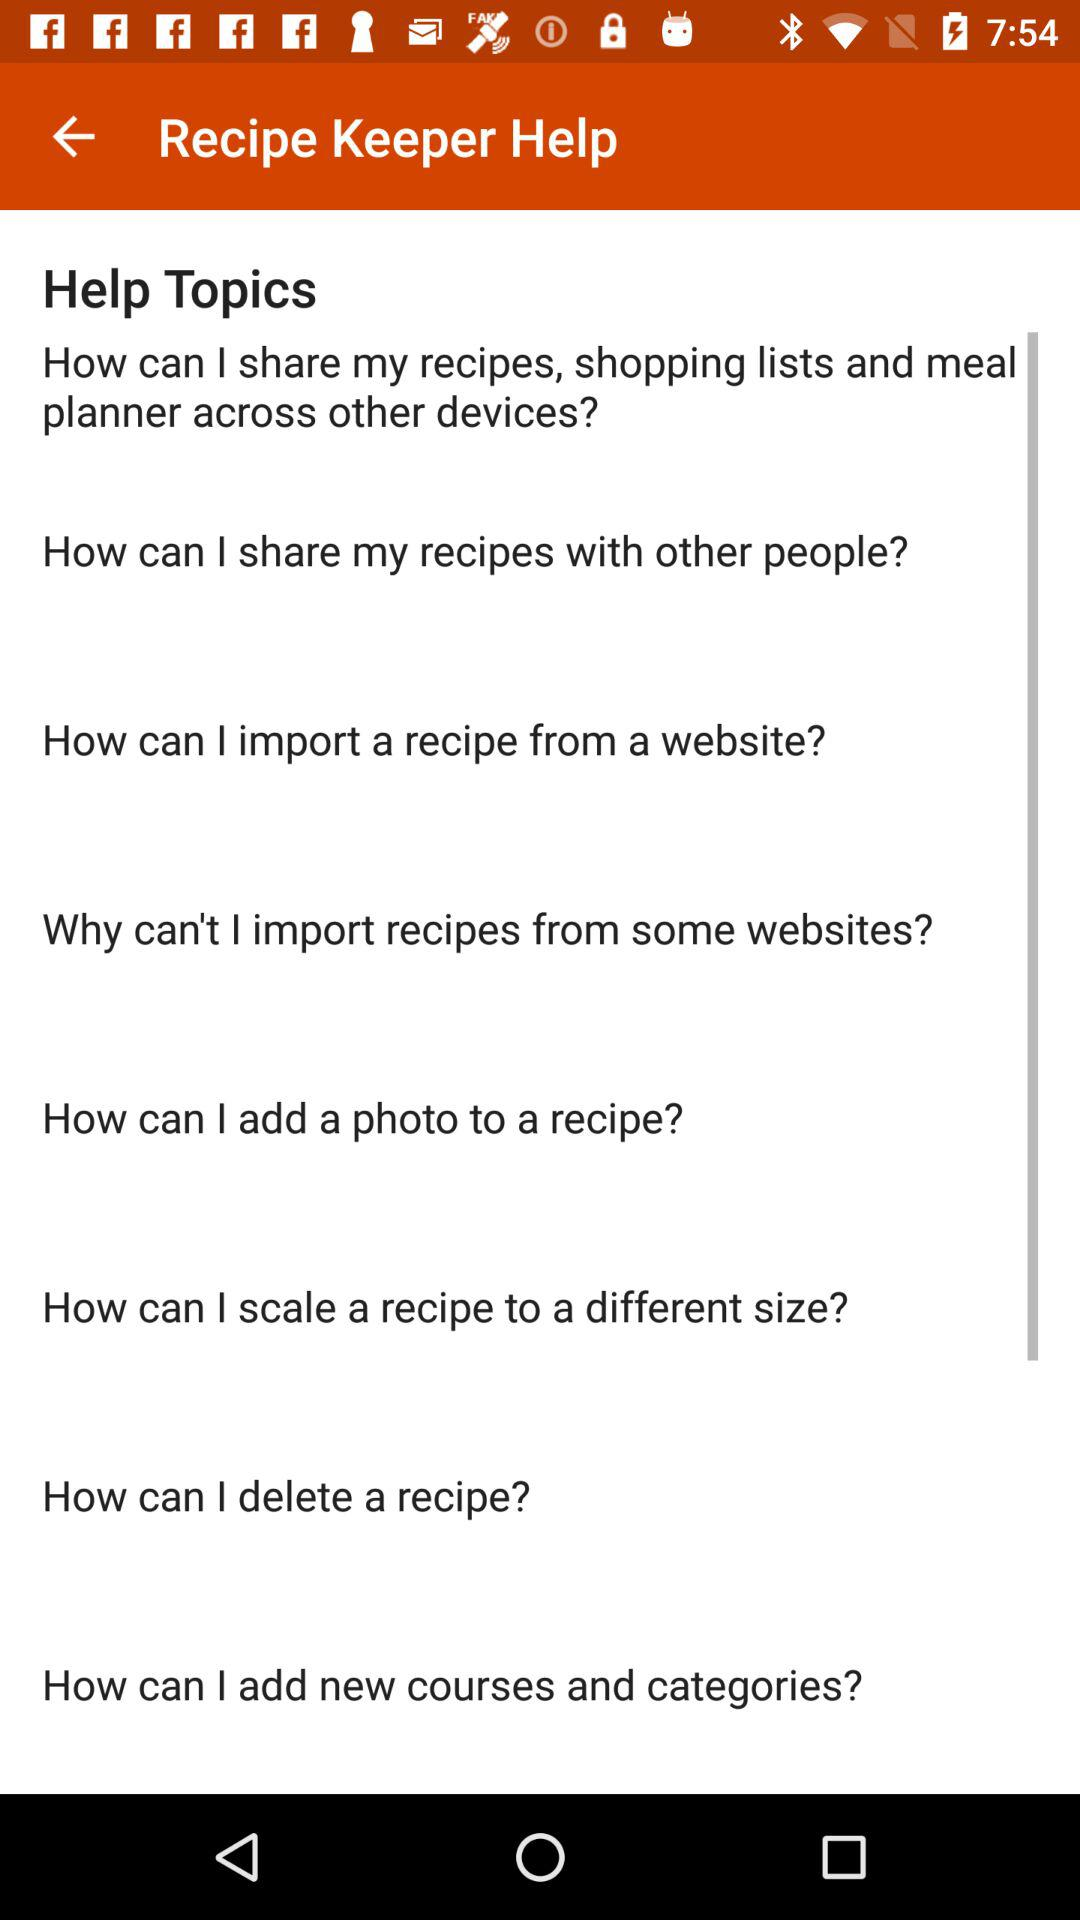What are the "Help Topics" covered? The "Help Topics" covered are "How can I share my recipes, shopping lists and meal planner across other devices?", "How can I share my recipes with other people?", "How can I import a recipe from a website?", "Why can't I import recipes from some websites?", "How can I add a photo to a recipe?", "How can I scale a recipe to a different size?", "How can I delete a recipe?" and "How can I add new courses and categories?". 